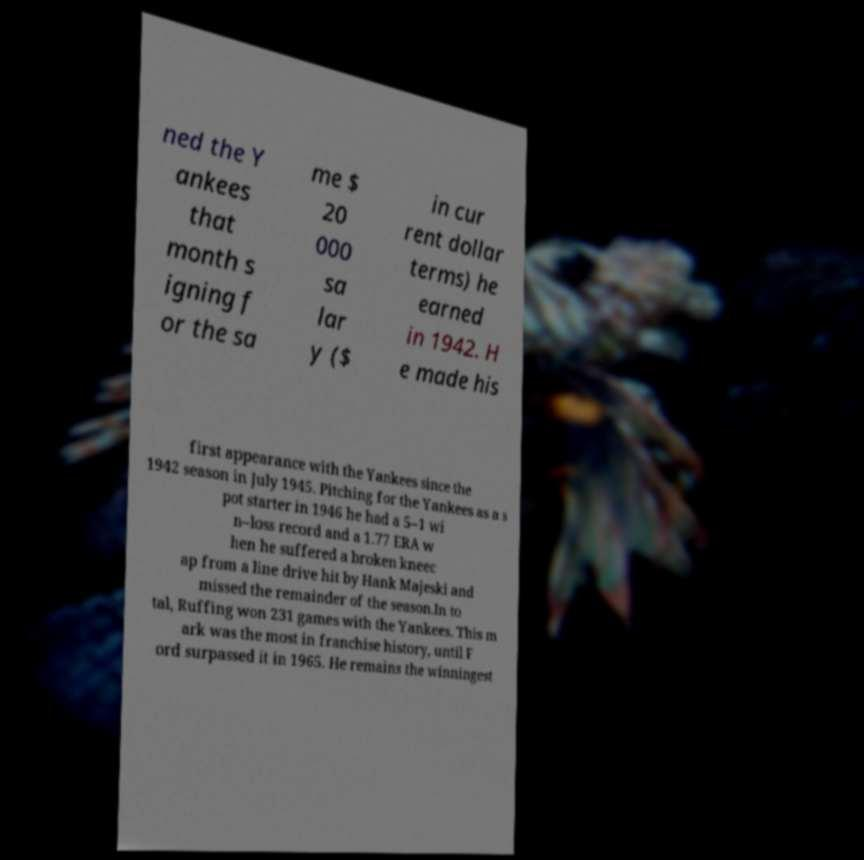Could you assist in decoding the text presented in this image and type it out clearly? ned the Y ankees that month s igning f or the sa me $ 20 000 sa lar y ($ in cur rent dollar terms) he earned in 1942. H e made his first appearance with the Yankees since the 1942 season in July 1945. Pitching for the Yankees as a s pot starter in 1946 he had a 5–1 wi n–loss record and a 1.77 ERA w hen he suffered a broken kneec ap from a line drive hit by Hank Majeski and missed the remainder of the season.In to tal, Ruffing won 231 games with the Yankees. This m ark was the most in franchise history, until F ord surpassed it in 1965. He remains the winningest 